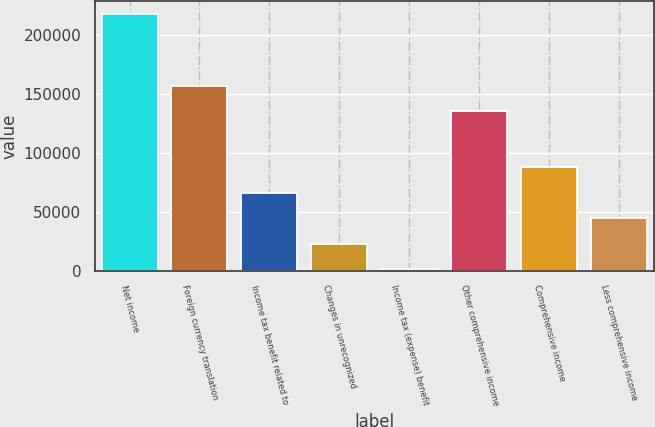Convert chart. <chart><loc_0><loc_0><loc_500><loc_500><bar_chart><fcel>Net income<fcel>Foreign currency translation<fcel>Income tax benefit related to<fcel>Changes in unrecognized<fcel>Income tax (expense) benefit<fcel>Other comprehensive income<fcel>Comprehensive income<fcel>Less comprehensive income<nl><fcel>217566<fcel>156684<fcel>66151.8<fcel>22890.6<fcel>1260<fcel>135053<fcel>87782.4<fcel>44521.2<nl></chart> 